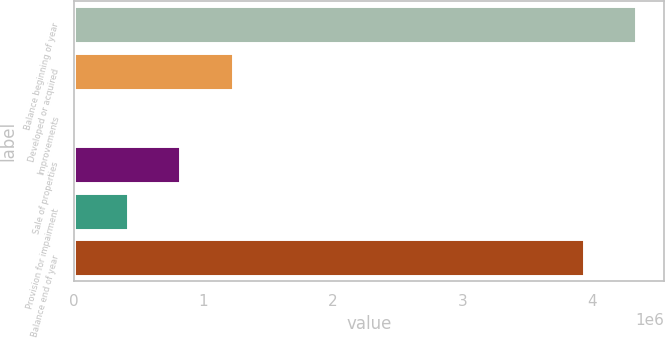Convert chart to OTSL. <chart><loc_0><loc_0><loc_500><loc_500><bar_chart><fcel>Balance beginning of year<fcel>Developed or acquired<fcel>Improvements<fcel>Sale of properties<fcel>Provision for impairment<fcel>Balance end of year<nl><fcel>4.33646e+06<fcel>1.22368e+06<fcel>15617<fcel>820991<fcel>418304<fcel>3.93378e+06<nl></chart> 